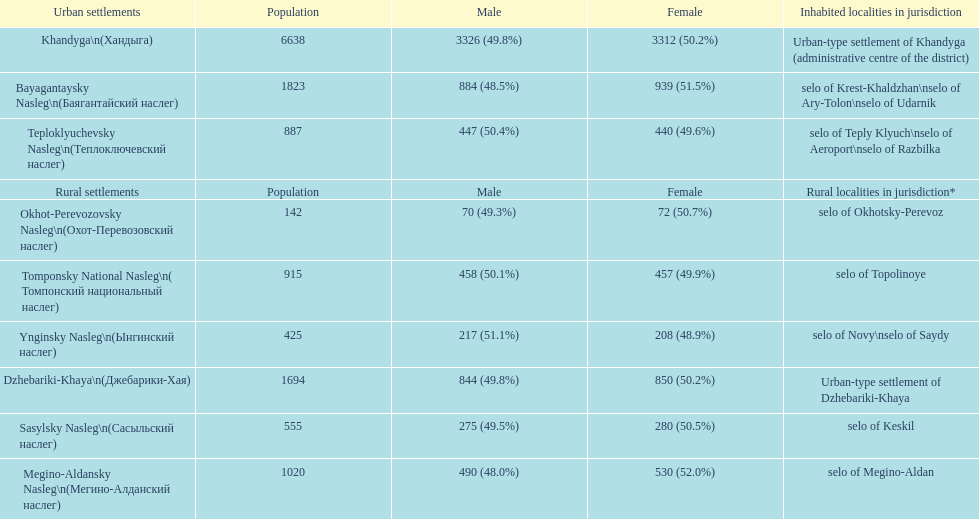What is the total population in dzhebariki-khaya? 1694. 